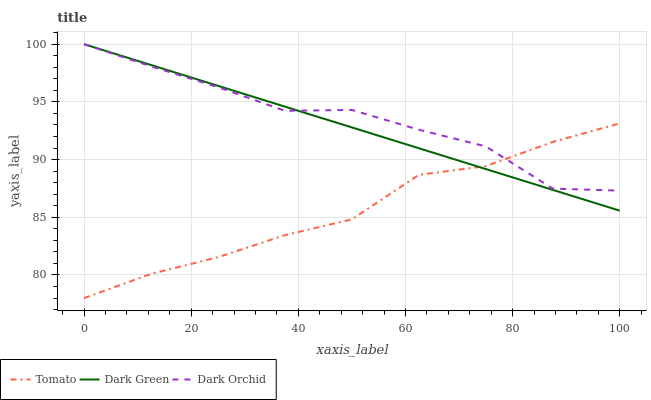Does Tomato have the minimum area under the curve?
Answer yes or no. Yes. Does Dark Orchid have the maximum area under the curve?
Answer yes or no. Yes. Does Dark Green have the minimum area under the curve?
Answer yes or no. No. Does Dark Green have the maximum area under the curve?
Answer yes or no. No. Is Dark Green the smoothest?
Answer yes or no. Yes. Is Dark Orchid the roughest?
Answer yes or no. Yes. Is Dark Orchid the smoothest?
Answer yes or no. No. Is Dark Green the roughest?
Answer yes or no. No. Does Tomato have the lowest value?
Answer yes or no. Yes. Does Dark Green have the lowest value?
Answer yes or no. No. Does Dark Green have the highest value?
Answer yes or no. Yes. Does Dark Green intersect Dark Orchid?
Answer yes or no. Yes. Is Dark Green less than Dark Orchid?
Answer yes or no. No. Is Dark Green greater than Dark Orchid?
Answer yes or no. No. 